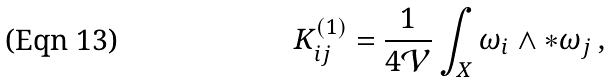<formula> <loc_0><loc_0><loc_500><loc_500>K ^ { \left ( 1 \right ) } _ { i j } = \frac { 1 } { 4 \mathcal { V } } \int _ { X } \omega _ { i } \wedge * \omega _ { j } \, ,</formula> 